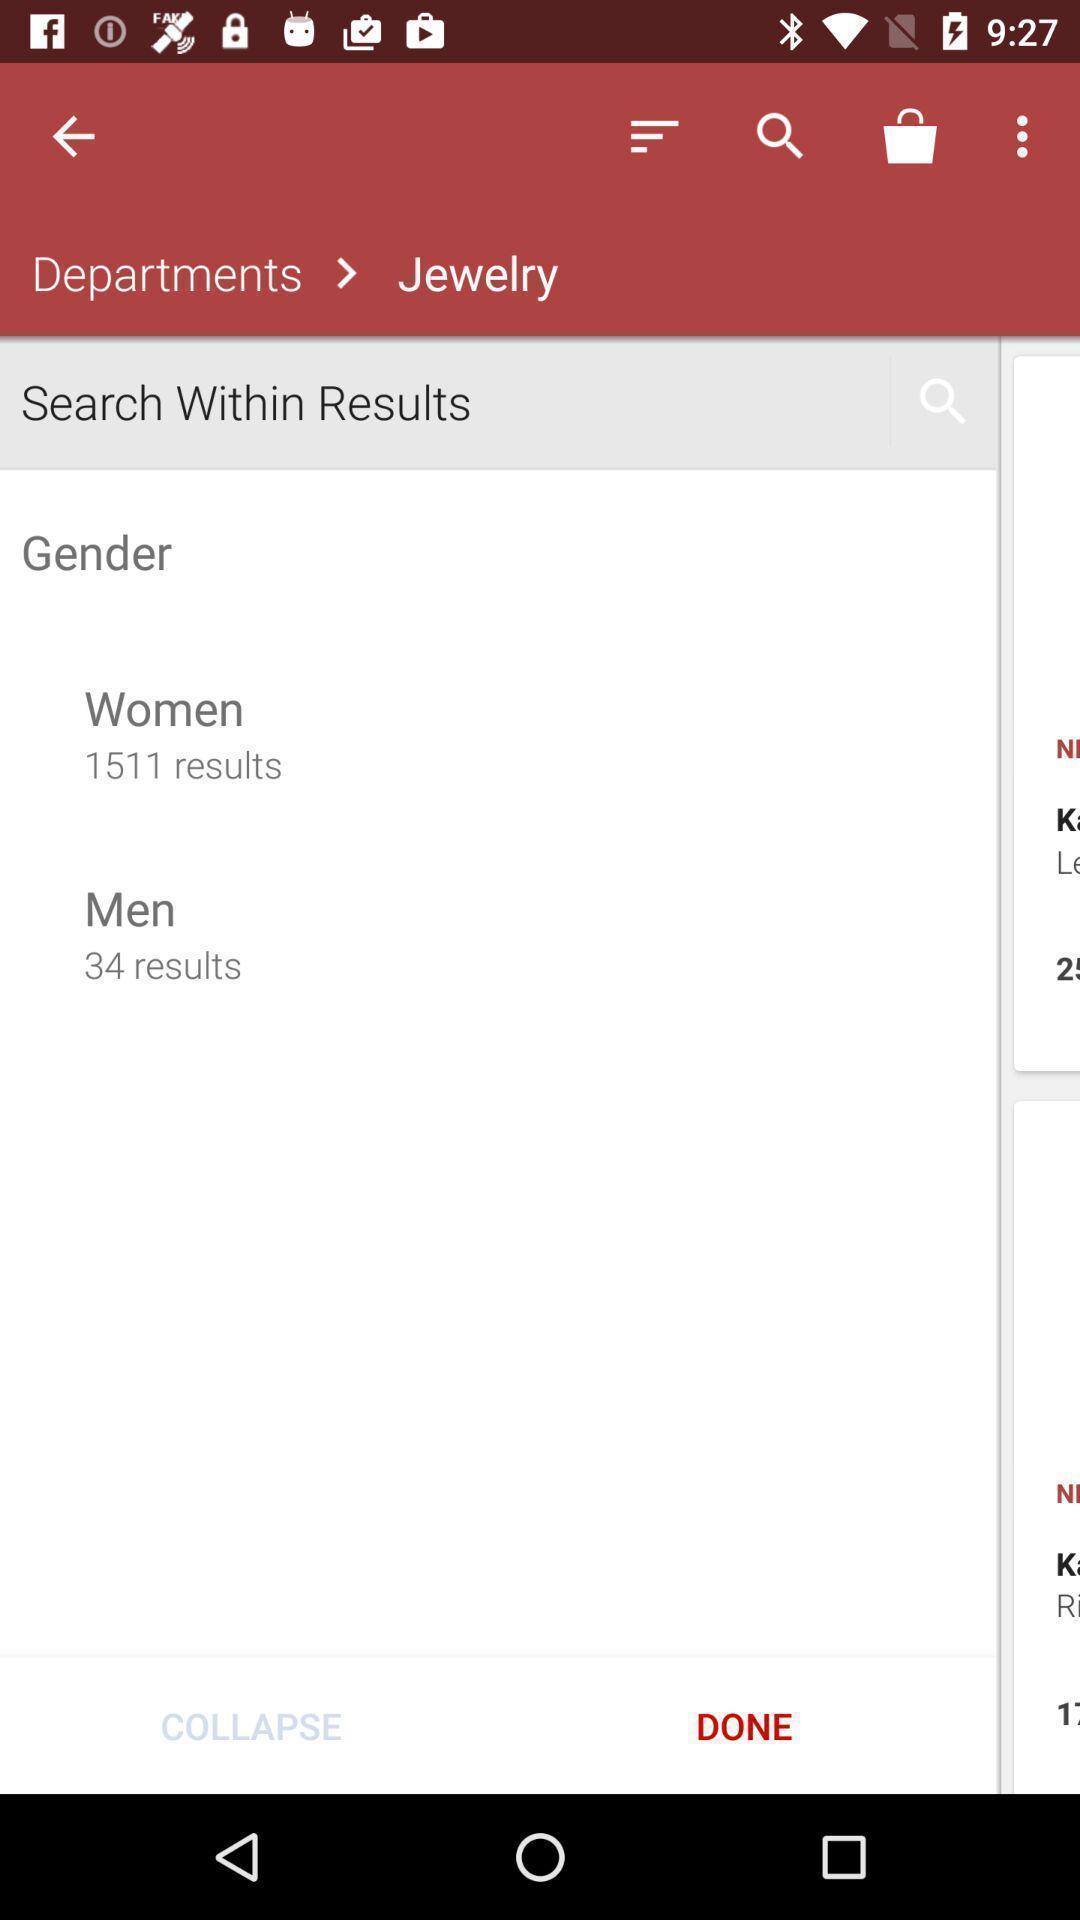Provide a description of this screenshot. Screen displaying multiple options in a shopping application. 